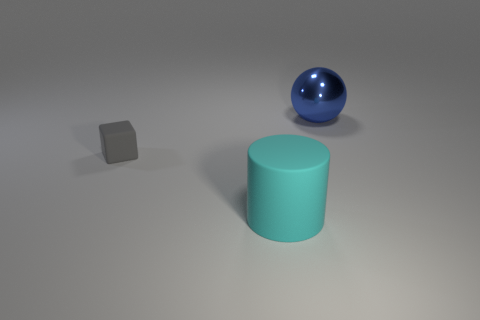Are there any big metal balls?
Your answer should be compact. Yes. Does the thing that is on the right side of the cyan thing have the same color as the matte cube?
Give a very brief answer. No. Does the blue metal object have the same size as the matte cylinder?
Ensure brevity in your answer.  Yes. There is a big thing that is the same material as the small cube; what is its shape?
Offer a very short reply. Cylinder. How many other things are the same shape as the gray thing?
Offer a very short reply. 0. The object that is behind the rubber object that is to the left of the big thing in front of the large metallic ball is what shape?
Ensure brevity in your answer.  Sphere. What number of blocks are either big blue metal objects or big cyan things?
Ensure brevity in your answer.  0. There is a cyan cylinder in front of the small gray block; is there a large thing on the right side of it?
Your answer should be compact. Yes. Is there any other thing that is the same material as the large sphere?
Make the answer very short. No. What number of other things are there of the same size as the blue shiny object?
Ensure brevity in your answer.  1. 